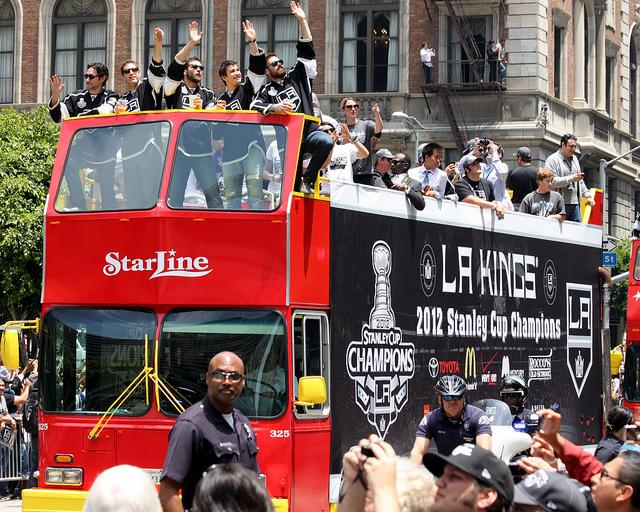What kind of team is this celebrating?

Choices:
A) nfl football
B) mlb baseball
C) nhl hockey
D) nba basketball nhl hockey 